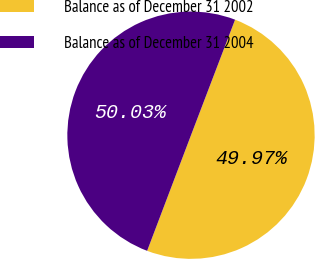Convert chart to OTSL. <chart><loc_0><loc_0><loc_500><loc_500><pie_chart><fcel>Balance as of December 31 2002<fcel>Balance as of December 31 2004<nl><fcel>49.97%<fcel>50.03%<nl></chart> 